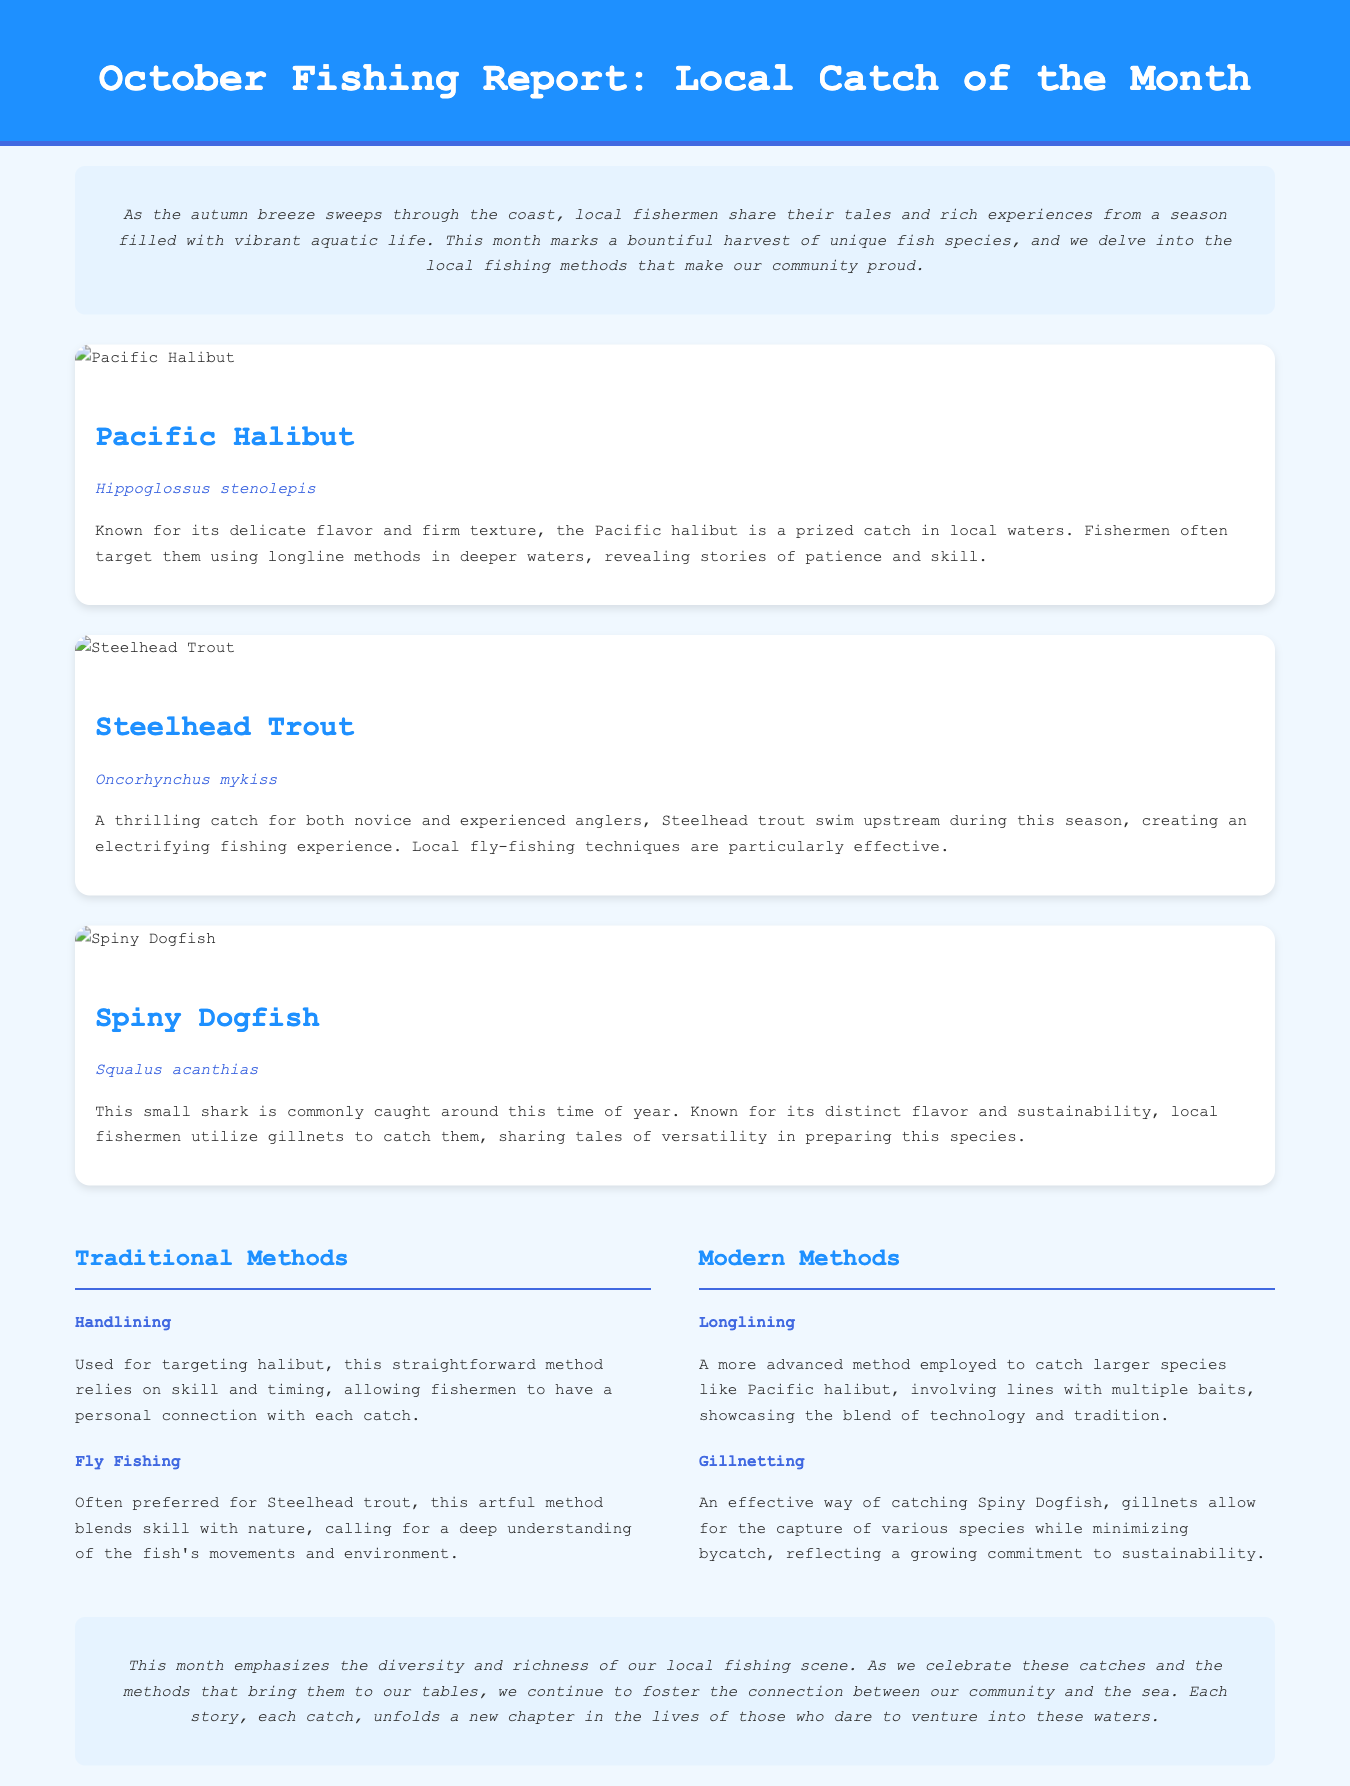What is the title of the fishing report? The title is found in the header of the document, which introduces the report for the month.
Answer: October Fishing Report: Local Catch of the Month How many unique fish species are highlighted in the report? The report discusses three different fish species, each detailed in separate fish cards.
Answer: Three What fishing method is used for targeting halibut? The method for halibut is mentioned in the traditional methods section of the document.
Answer: Handlining What is the scientific name of Steelhead Trout? The scientific name is included directly under the fish's name in the fish card for Steelhead Trout.
Answer: Oncorhynchus mykiss Which fish is commonly caught using gillnets? The fish caught with gillnets is mentioned in the context of local fishing methods for sustainability.
Answer: Spiny Dogfish Which month does this fishing report focus on? The report specifically addresses fishing activities for a particular month as indicated in the title.
Answer: October What color is the background of the introduction section? The introduction section describes its background color, which adds to its visual style.
Answer: Light blue Which traditional fishing method is preferred for Steelhead Trout? The report specifies the preferred fishing method for Steelhead Trout, indicating its suitability.
Answer: Fly Fishing What is the price of Pacific Halibut? The report does not explicitly mention prices, but the fishing quality and characteristics are discussed instead.
Answer: Not mentioned 